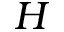Convert formula to latex. <formula><loc_0><loc_0><loc_500><loc_500>H</formula> 